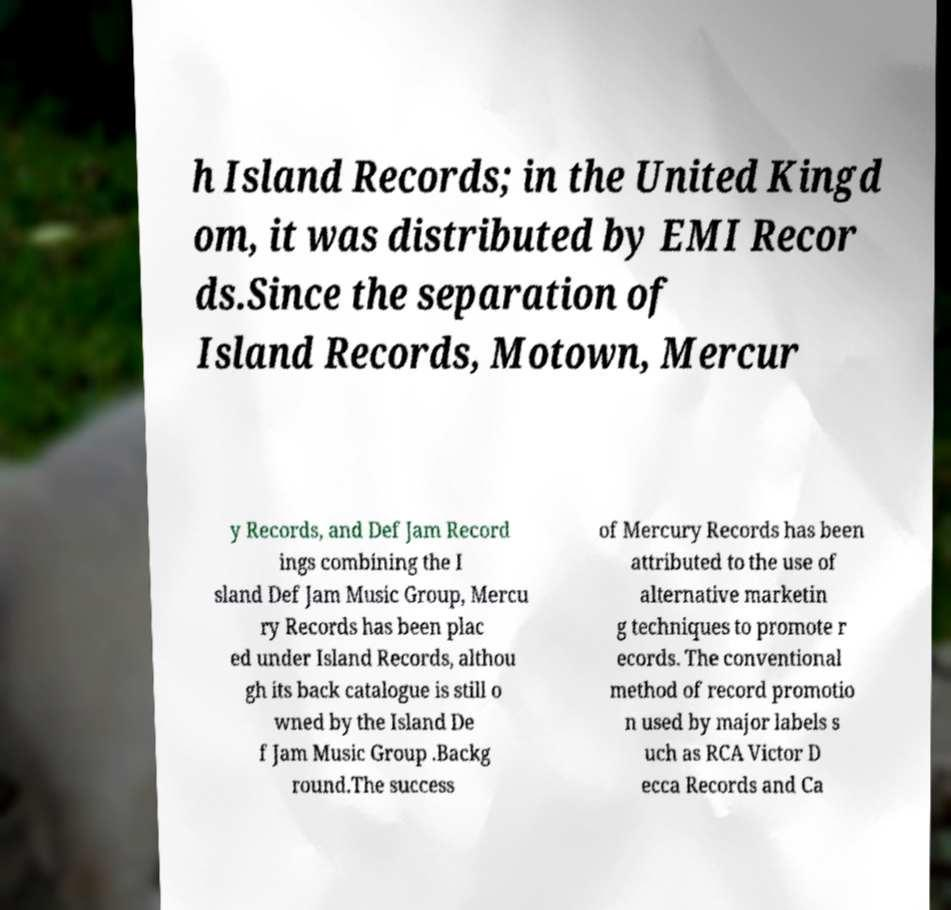Can you accurately transcribe the text from the provided image for me? h Island Records; in the United Kingd om, it was distributed by EMI Recor ds.Since the separation of Island Records, Motown, Mercur y Records, and Def Jam Record ings combining the I sland Def Jam Music Group, Mercu ry Records has been plac ed under Island Records, althou gh its back catalogue is still o wned by the Island De f Jam Music Group .Backg round.The success of Mercury Records has been attributed to the use of alternative marketin g techniques to promote r ecords. The conventional method of record promotio n used by major labels s uch as RCA Victor D ecca Records and Ca 